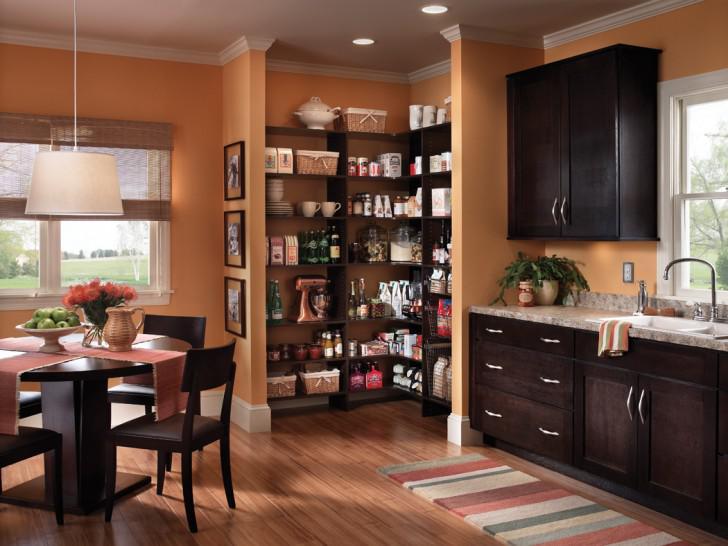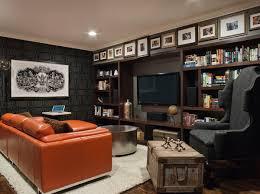The first image is the image on the left, the second image is the image on the right. Assess this claim about the two images: "There are at most three picture frames.". Correct or not? Answer yes or no. No. The first image is the image on the left, the second image is the image on the right. For the images shown, is this caption "In at least one image there is a cream colored sofa chair with a dark blanket folded and draped over the sofa chair with a yellow lamp to the left of the chair." true? Answer yes or no. No. 